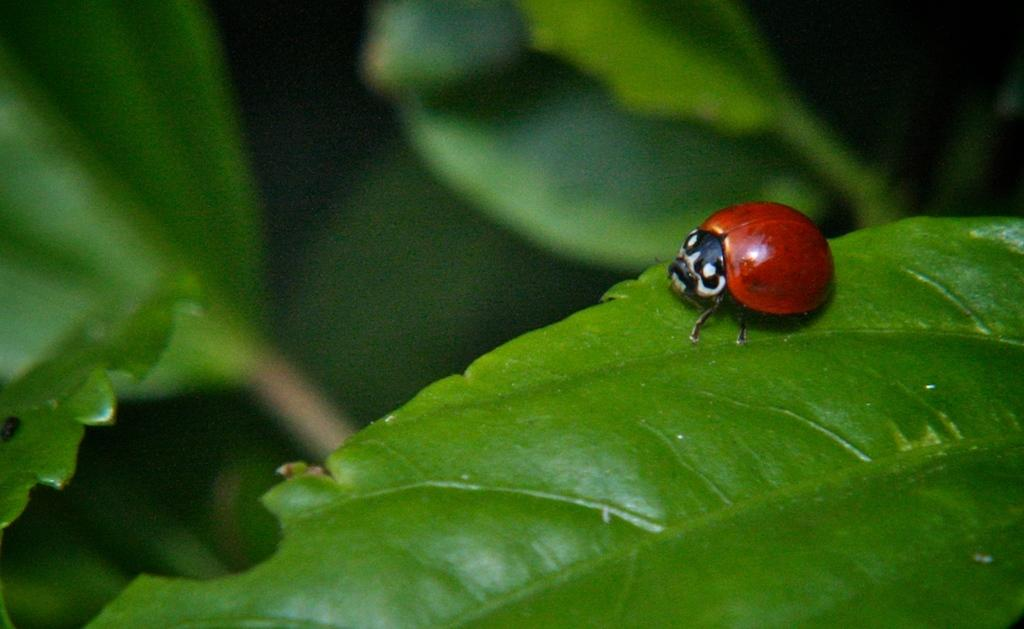What is present in the image? There is a bug in the image. Where is the bug located? The bug is on a leaf. What type of print is visible on the bug's back? There is no print visible on the bug's back in the image. 